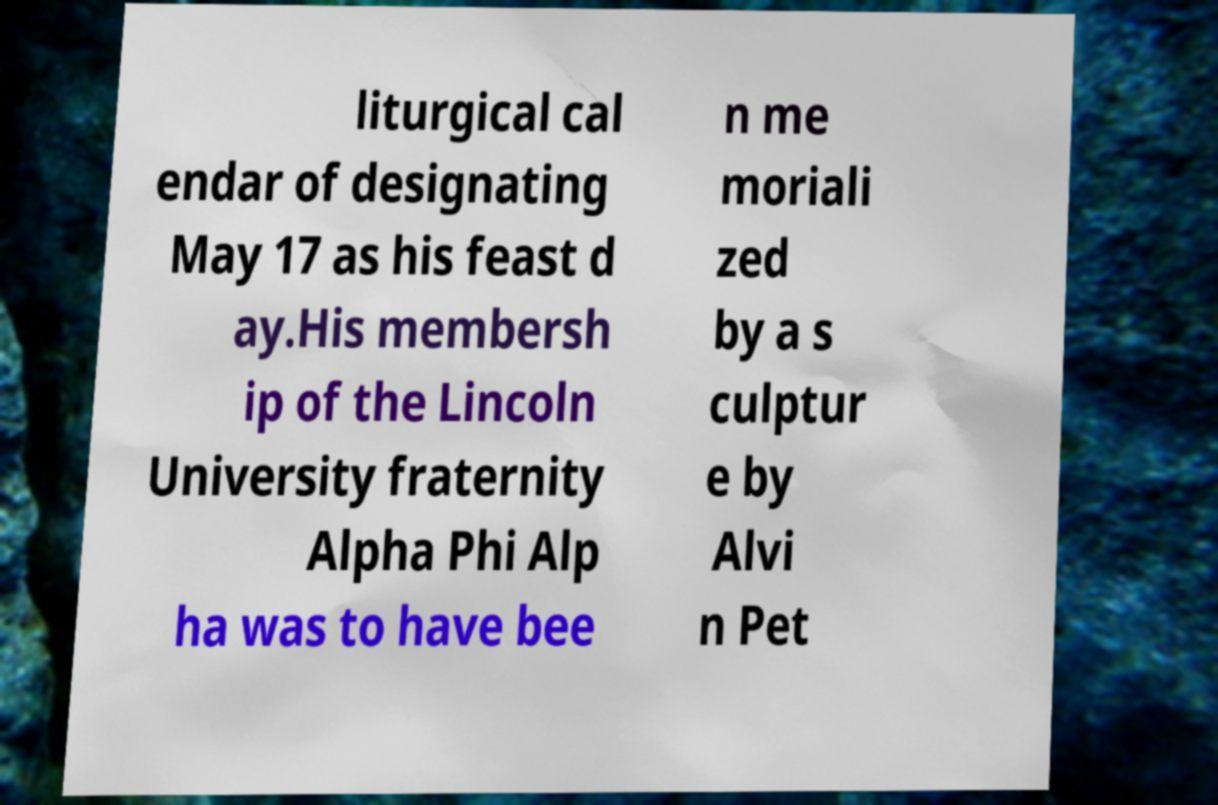Could you extract and type out the text from this image? liturgical cal endar of designating May 17 as his feast d ay.His membersh ip of the Lincoln University fraternity Alpha Phi Alp ha was to have bee n me moriali zed by a s culptur e by Alvi n Pet 